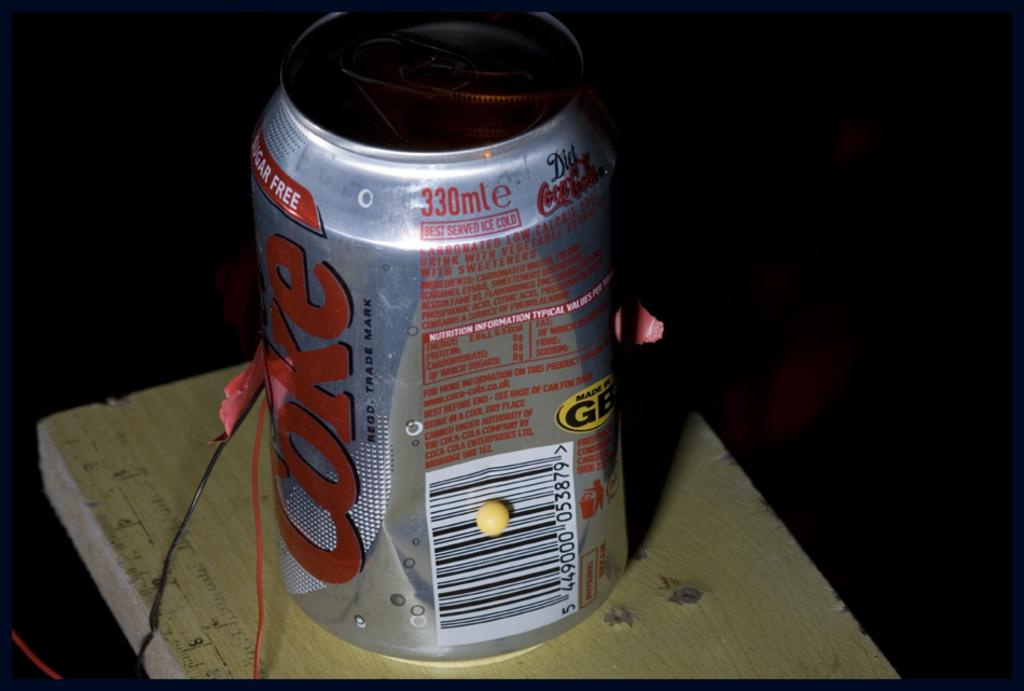<image>
Give a short and clear explanation of the subsequent image. A Coke can says it contains 330 milliliters of soda. 